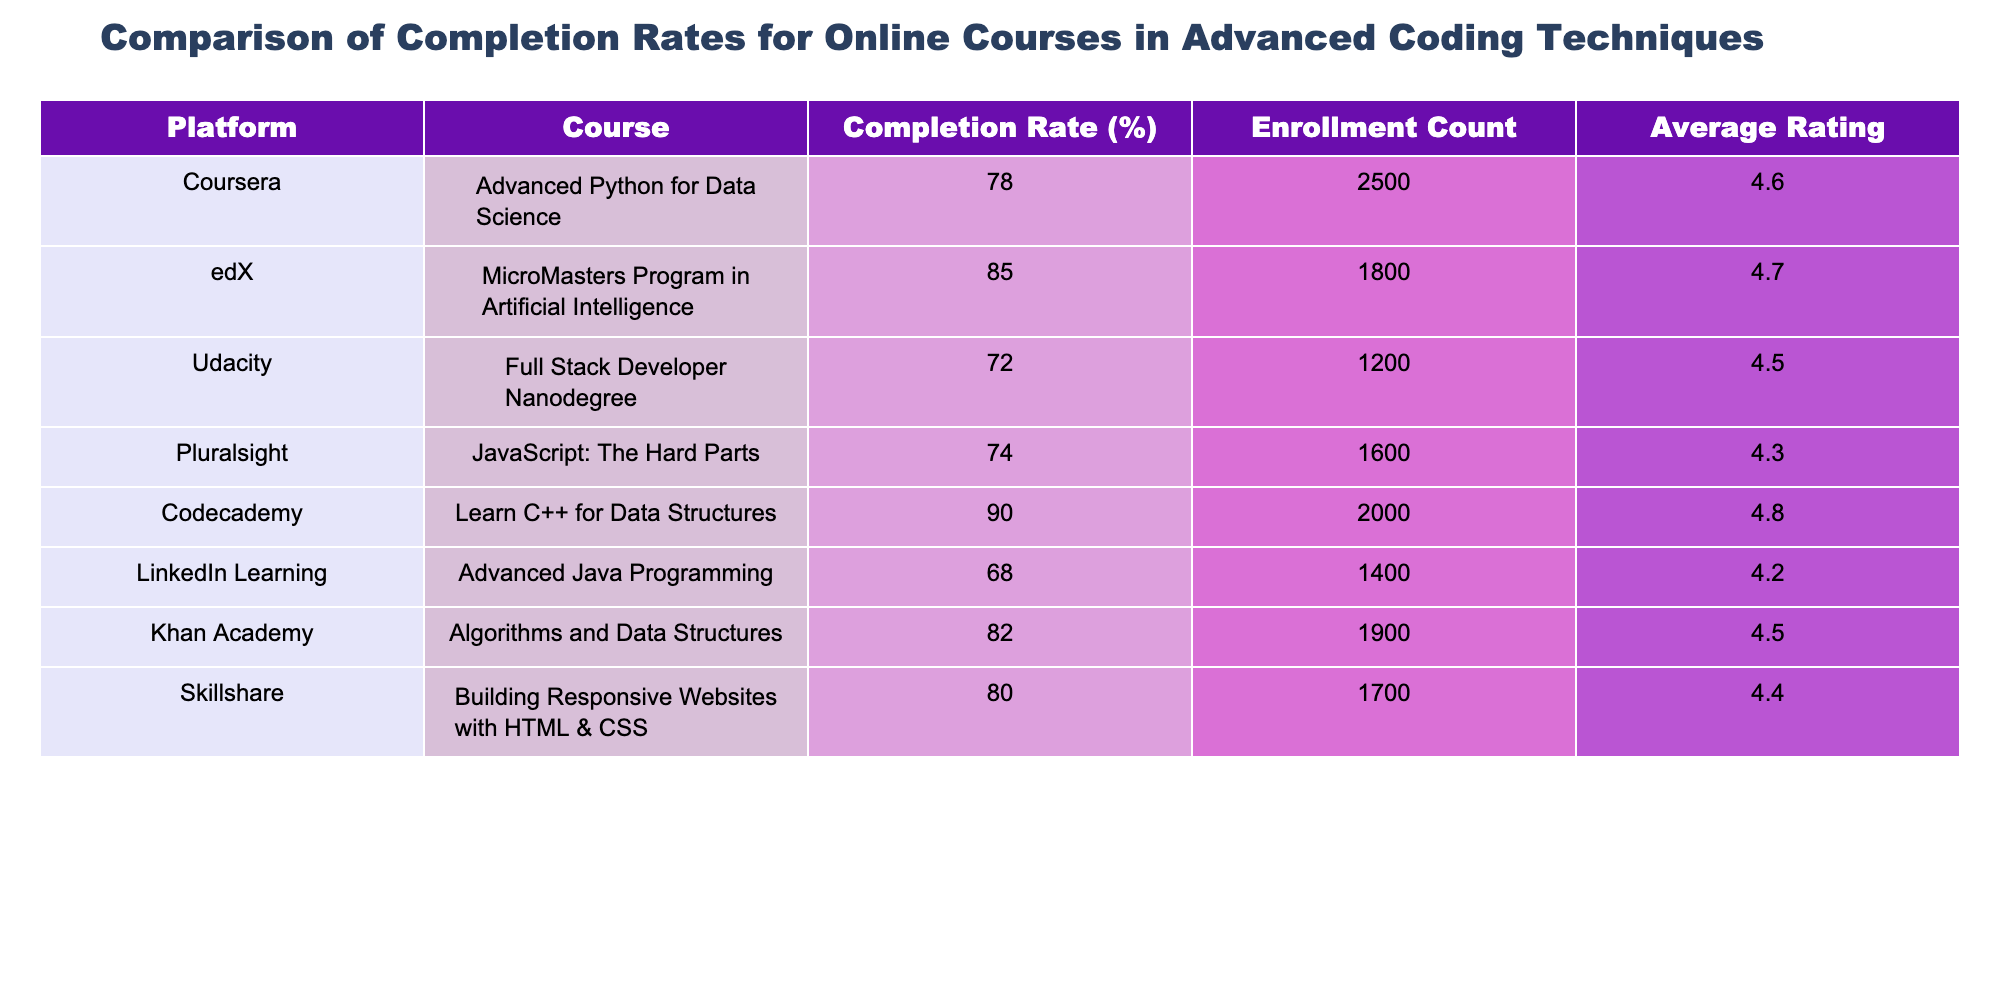What is the completion rate for the "MicroMasters Program in Artificial Intelligence" on edX? The table shows the row for the "MicroMasters Program in Artificial Intelligence" under the edX platform, which indicates a completion rate of 85%.
Answer: 85 Which platform has the highest average rating for its course? By examining the "Average Rating" column, the "Learn C++ for Data Structures" course on Codecademy has the highest rating of 4.8.
Answer: Codecademy What is the sum of enrollment counts for all courses listed? To find the sum, we add the enrollment counts: 2500 + 1800 + 1200 + 1600 + 2000 + 1400 + 1900 + 1700 = 13600.
Answer: 13600 Is the completion rate for the "Advanced Java Programming" course on LinkedIn Learning lower than 70%? The "Advanced Java Programming" course has a completion rate of 68%, which indeed is lower than 70%.
Answer: Yes Which course offers the lowest completion rate and what is that rate? The lowest completion rate is found in the "Full Stack Developer Nanodegree" on Udacity, with a rate of 72%.
Answer: 72 If we average the completion rates of the courses on Coursera and Pluralsight, what would the average be? The completion rates for Coursera's and Pluralsight's courses are 78% and 74%, respectively. Adding these gives 78 + 74 = 152, and dividing by 2 gives an average of 76%.
Answer: 76 Does the "Algorithms and Data Structures" course have a higher enrollment count than the "JavaScript: The Hard Parts"? The enrollment count for "Algorithms and Data Structures" is 1900, while for "JavaScript: The Hard Parts," it is 1600. Thus, it does have a higher count.
Answer: Yes What is the difference in completion rates between Codecademy and Khan Academy courses? Codecademy's completion rate is 90% and Khan Academy's is 82%. The difference is 90 - 82 = 8%.
Answer: 8 What is the average completion rate for all listed courses? The individual completion rates are: 78, 85, 72, 74, 90, 68, 82, 80. The sum is 78 + 85 + 72 + 74 + 90 + 68 + 82 + 80 = 629. Dividing by 8 gives the average of 78.625%.
Answer: 78.625 